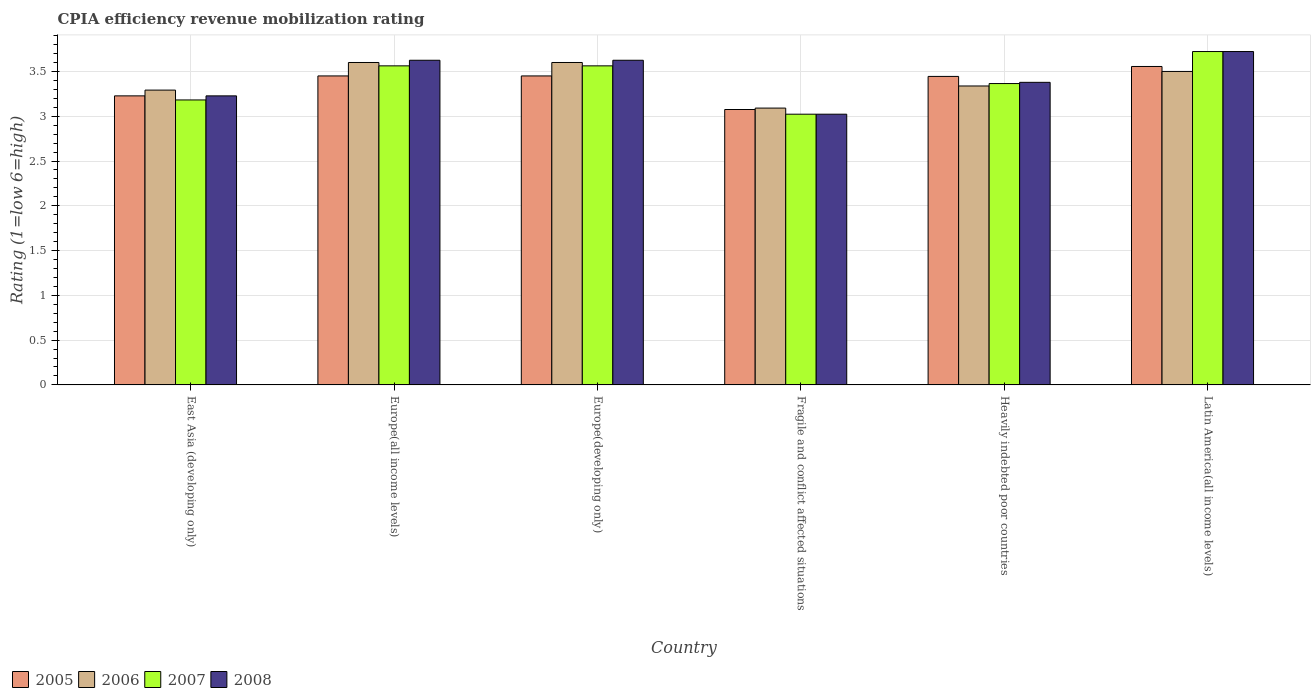How many different coloured bars are there?
Give a very brief answer. 4. Are the number of bars per tick equal to the number of legend labels?
Ensure brevity in your answer.  Yes. What is the label of the 3rd group of bars from the left?
Offer a very short reply. Europe(developing only). In how many cases, is the number of bars for a given country not equal to the number of legend labels?
Provide a succinct answer. 0. What is the CPIA rating in 2005 in Latin America(all income levels)?
Make the answer very short. 3.56. Across all countries, what is the maximum CPIA rating in 2005?
Provide a succinct answer. 3.56. Across all countries, what is the minimum CPIA rating in 2005?
Offer a terse response. 3.08. In which country was the CPIA rating in 2008 maximum?
Offer a terse response. Latin America(all income levels). In which country was the CPIA rating in 2006 minimum?
Your response must be concise. Fragile and conflict affected situations. What is the total CPIA rating in 2008 in the graph?
Your answer should be very brief. 20.6. What is the difference between the CPIA rating in 2005 in Europe(developing only) and that in Heavily indebted poor countries?
Provide a short and direct response. 0.01. What is the difference between the CPIA rating in 2008 in Europe(developing only) and the CPIA rating in 2005 in East Asia (developing only)?
Provide a succinct answer. 0.4. What is the average CPIA rating in 2008 per country?
Your answer should be compact. 3.43. What is the difference between the CPIA rating of/in 2006 and CPIA rating of/in 2005 in Heavily indebted poor countries?
Give a very brief answer. -0.11. What is the ratio of the CPIA rating in 2007 in Europe(all income levels) to that in Heavily indebted poor countries?
Your answer should be compact. 1.06. Is the CPIA rating in 2008 in Europe(developing only) less than that in Latin America(all income levels)?
Provide a short and direct response. Yes. What is the difference between the highest and the second highest CPIA rating in 2005?
Your answer should be compact. -0.11. What is the difference between the highest and the lowest CPIA rating in 2007?
Your answer should be compact. 0.7. In how many countries, is the CPIA rating in 2005 greater than the average CPIA rating in 2005 taken over all countries?
Ensure brevity in your answer.  4. Is the sum of the CPIA rating in 2008 in Europe(developing only) and Heavily indebted poor countries greater than the maximum CPIA rating in 2007 across all countries?
Your answer should be very brief. Yes. Is it the case that in every country, the sum of the CPIA rating in 2005 and CPIA rating in 2006 is greater than the sum of CPIA rating in 2007 and CPIA rating in 2008?
Offer a terse response. No. What does the 4th bar from the left in Latin America(all income levels) represents?
Your answer should be very brief. 2008. Are all the bars in the graph horizontal?
Your answer should be very brief. No. What is the difference between two consecutive major ticks on the Y-axis?
Ensure brevity in your answer.  0.5. Does the graph contain any zero values?
Provide a short and direct response. No. Where does the legend appear in the graph?
Offer a very short reply. Bottom left. How are the legend labels stacked?
Make the answer very short. Horizontal. What is the title of the graph?
Ensure brevity in your answer.  CPIA efficiency revenue mobilization rating. What is the label or title of the X-axis?
Offer a terse response. Country. What is the label or title of the Y-axis?
Offer a terse response. Rating (1=low 6=high). What is the Rating (1=low 6=high) in 2005 in East Asia (developing only)?
Your response must be concise. 3.23. What is the Rating (1=low 6=high) in 2006 in East Asia (developing only)?
Provide a short and direct response. 3.29. What is the Rating (1=low 6=high) of 2007 in East Asia (developing only)?
Your response must be concise. 3.18. What is the Rating (1=low 6=high) of 2008 in East Asia (developing only)?
Make the answer very short. 3.23. What is the Rating (1=low 6=high) of 2005 in Europe(all income levels)?
Provide a short and direct response. 3.45. What is the Rating (1=low 6=high) of 2006 in Europe(all income levels)?
Give a very brief answer. 3.6. What is the Rating (1=low 6=high) of 2007 in Europe(all income levels)?
Offer a terse response. 3.56. What is the Rating (1=low 6=high) in 2008 in Europe(all income levels)?
Keep it short and to the point. 3.62. What is the Rating (1=low 6=high) in 2005 in Europe(developing only)?
Your response must be concise. 3.45. What is the Rating (1=low 6=high) of 2007 in Europe(developing only)?
Your answer should be compact. 3.56. What is the Rating (1=low 6=high) of 2008 in Europe(developing only)?
Make the answer very short. 3.62. What is the Rating (1=low 6=high) in 2005 in Fragile and conflict affected situations?
Make the answer very short. 3.08. What is the Rating (1=low 6=high) of 2006 in Fragile and conflict affected situations?
Provide a succinct answer. 3.09. What is the Rating (1=low 6=high) of 2007 in Fragile and conflict affected situations?
Ensure brevity in your answer.  3.02. What is the Rating (1=low 6=high) in 2008 in Fragile and conflict affected situations?
Offer a very short reply. 3.02. What is the Rating (1=low 6=high) of 2005 in Heavily indebted poor countries?
Make the answer very short. 3.44. What is the Rating (1=low 6=high) in 2006 in Heavily indebted poor countries?
Your answer should be compact. 3.34. What is the Rating (1=low 6=high) of 2007 in Heavily indebted poor countries?
Ensure brevity in your answer.  3.36. What is the Rating (1=low 6=high) of 2008 in Heavily indebted poor countries?
Ensure brevity in your answer.  3.38. What is the Rating (1=low 6=high) of 2005 in Latin America(all income levels)?
Your answer should be compact. 3.56. What is the Rating (1=low 6=high) in 2007 in Latin America(all income levels)?
Ensure brevity in your answer.  3.72. What is the Rating (1=low 6=high) of 2008 in Latin America(all income levels)?
Make the answer very short. 3.72. Across all countries, what is the maximum Rating (1=low 6=high) of 2005?
Provide a succinct answer. 3.56. Across all countries, what is the maximum Rating (1=low 6=high) in 2006?
Your answer should be very brief. 3.6. Across all countries, what is the maximum Rating (1=low 6=high) in 2007?
Provide a succinct answer. 3.72. Across all countries, what is the maximum Rating (1=low 6=high) in 2008?
Provide a succinct answer. 3.72. Across all countries, what is the minimum Rating (1=low 6=high) in 2005?
Your answer should be compact. 3.08. Across all countries, what is the minimum Rating (1=low 6=high) of 2006?
Provide a succinct answer. 3.09. Across all countries, what is the minimum Rating (1=low 6=high) of 2007?
Provide a succinct answer. 3.02. Across all countries, what is the minimum Rating (1=low 6=high) in 2008?
Offer a terse response. 3.02. What is the total Rating (1=low 6=high) in 2005 in the graph?
Make the answer very short. 20.2. What is the total Rating (1=low 6=high) in 2006 in the graph?
Make the answer very short. 20.42. What is the total Rating (1=low 6=high) in 2007 in the graph?
Offer a terse response. 20.42. What is the total Rating (1=low 6=high) in 2008 in the graph?
Keep it short and to the point. 20.6. What is the difference between the Rating (1=low 6=high) of 2005 in East Asia (developing only) and that in Europe(all income levels)?
Your response must be concise. -0.22. What is the difference between the Rating (1=low 6=high) of 2006 in East Asia (developing only) and that in Europe(all income levels)?
Keep it short and to the point. -0.31. What is the difference between the Rating (1=low 6=high) of 2007 in East Asia (developing only) and that in Europe(all income levels)?
Give a very brief answer. -0.38. What is the difference between the Rating (1=low 6=high) of 2008 in East Asia (developing only) and that in Europe(all income levels)?
Provide a succinct answer. -0.4. What is the difference between the Rating (1=low 6=high) in 2005 in East Asia (developing only) and that in Europe(developing only)?
Ensure brevity in your answer.  -0.22. What is the difference between the Rating (1=low 6=high) in 2006 in East Asia (developing only) and that in Europe(developing only)?
Provide a short and direct response. -0.31. What is the difference between the Rating (1=low 6=high) of 2007 in East Asia (developing only) and that in Europe(developing only)?
Offer a terse response. -0.38. What is the difference between the Rating (1=low 6=high) in 2008 in East Asia (developing only) and that in Europe(developing only)?
Your answer should be compact. -0.4. What is the difference between the Rating (1=low 6=high) of 2005 in East Asia (developing only) and that in Fragile and conflict affected situations?
Make the answer very short. 0.15. What is the difference between the Rating (1=low 6=high) of 2006 in East Asia (developing only) and that in Fragile and conflict affected situations?
Your response must be concise. 0.2. What is the difference between the Rating (1=low 6=high) of 2007 in East Asia (developing only) and that in Fragile and conflict affected situations?
Give a very brief answer. 0.16. What is the difference between the Rating (1=low 6=high) in 2008 in East Asia (developing only) and that in Fragile and conflict affected situations?
Provide a short and direct response. 0.2. What is the difference between the Rating (1=low 6=high) in 2005 in East Asia (developing only) and that in Heavily indebted poor countries?
Your response must be concise. -0.22. What is the difference between the Rating (1=low 6=high) in 2006 in East Asia (developing only) and that in Heavily indebted poor countries?
Your answer should be very brief. -0.05. What is the difference between the Rating (1=low 6=high) in 2007 in East Asia (developing only) and that in Heavily indebted poor countries?
Give a very brief answer. -0.18. What is the difference between the Rating (1=low 6=high) of 2008 in East Asia (developing only) and that in Heavily indebted poor countries?
Your answer should be compact. -0.15. What is the difference between the Rating (1=low 6=high) of 2005 in East Asia (developing only) and that in Latin America(all income levels)?
Provide a succinct answer. -0.33. What is the difference between the Rating (1=low 6=high) of 2006 in East Asia (developing only) and that in Latin America(all income levels)?
Provide a succinct answer. -0.21. What is the difference between the Rating (1=low 6=high) of 2007 in East Asia (developing only) and that in Latin America(all income levels)?
Your answer should be compact. -0.54. What is the difference between the Rating (1=low 6=high) in 2008 in East Asia (developing only) and that in Latin America(all income levels)?
Give a very brief answer. -0.49. What is the difference between the Rating (1=low 6=high) in 2008 in Europe(all income levels) and that in Europe(developing only)?
Provide a succinct answer. 0. What is the difference between the Rating (1=low 6=high) of 2006 in Europe(all income levels) and that in Fragile and conflict affected situations?
Make the answer very short. 0.51. What is the difference between the Rating (1=low 6=high) in 2007 in Europe(all income levels) and that in Fragile and conflict affected situations?
Keep it short and to the point. 0.54. What is the difference between the Rating (1=low 6=high) of 2008 in Europe(all income levels) and that in Fragile and conflict affected situations?
Offer a terse response. 0.6. What is the difference between the Rating (1=low 6=high) in 2005 in Europe(all income levels) and that in Heavily indebted poor countries?
Provide a short and direct response. 0.01. What is the difference between the Rating (1=low 6=high) in 2006 in Europe(all income levels) and that in Heavily indebted poor countries?
Your response must be concise. 0.26. What is the difference between the Rating (1=low 6=high) in 2007 in Europe(all income levels) and that in Heavily indebted poor countries?
Make the answer very short. 0.2. What is the difference between the Rating (1=low 6=high) in 2008 in Europe(all income levels) and that in Heavily indebted poor countries?
Offer a very short reply. 0.25. What is the difference between the Rating (1=low 6=high) in 2005 in Europe(all income levels) and that in Latin America(all income levels)?
Ensure brevity in your answer.  -0.11. What is the difference between the Rating (1=low 6=high) in 2006 in Europe(all income levels) and that in Latin America(all income levels)?
Your answer should be compact. 0.1. What is the difference between the Rating (1=low 6=high) of 2007 in Europe(all income levels) and that in Latin America(all income levels)?
Provide a short and direct response. -0.16. What is the difference between the Rating (1=low 6=high) of 2008 in Europe(all income levels) and that in Latin America(all income levels)?
Offer a very short reply. -0.1. What is the difference between the Rating (1=low 6=high) in 2006 in Europe(developing only) and that in Fragile and conflict affected situations?
Offer a terse response. 0.51. What is the difference between the Rating (1=low 6=high) of 2007 in Europe(developing only) and that in Fragile and conflict affected situations?
Provide a succinct answer. 0.54. What is the difference between the Rating (1=low 6=high) of 2008 in Europe(developing only) and that in Fragile and conflict affected situations?
Give a very brief answer. 0.6. What is the difference between the Rating (1=low 6=high) in 2005 in Europe(developing only) and that in Heavily indebted poor countries?
Ensure brevity in your answer.  0.01. What is the difference between the Rating (1=low 6=high) of 2006 in Europe(developing only) and that in Heavily indebted poor countries?
Your response must be concise. 0.26. What is the difference between the Rating (1=low 6=high) of 2007 in Europe(developing only) and that in Heavily indebted poor countries?
Offer a very short reply. 0.2. What is the difference between the Rating (1=low 6=high) in 2008 in Europe(developing only) and that in Heavily indebted poor countries?
Offer a terse response. 0.25. What is the difference between the Rating (1=low 6=high) in 2005 in Europe(developing only) and that in Latin America(all income levels)?
Offer a very short reply. -0.11. What is the difference between the Rating (1=low 6=high) of 2007 in Europe(developing only) and that in Latin America(all income levels)?
Offer a terse response. -0.16. What is the difference between the Rating (1=low 6=high) of 2008 in Europe(developing only) and that in Latin America(all income levels)?
Give a very brief answer. -0.1. What is the difference between the Rating (1=low 6=high) in 2005 in Fragile and conflict affected situations and that in Heavily indebted poor countries?
Offer a terse response. -0.37. What is the difference between the Rating (1=low 6=high) of 2006 in Fragile and conflict affected situations and that in Heavily indebted poor countries?
Provide a short and direct response. -0.25. What is the difference between the Rating (1=low 6=high) in 2007 in Fragile and conflict affected situations and that in Heavily indebted poor countries?
Offer a very short reply. -0.34. What is the difference between the Rating (1=low 6=high) in 2008 in Fragile and conflict affected situations and that in Heavily indebted poor countries?
Provide a succinct answer. -0.36. What is the difference between the Rating (1=low 6=high) in 2005 in Fragile and conflict affected situations and that in Latin America(all income levels)?
Give a very brief answer. -0.48. What is the difference between the Rating (1=low 6=high) in 2006 in Fragile and conflict affected situations and that in Latin America(all income levels)?
Keep it short and to the point. -0.41. What is the difference between the Rating (1=low 6=high) of 2007 in Fragile and conflict affected situations and that in Latin America(all income levels)?
Give a very brief answer. -0.7. What is the difference between the Rating (1=low 6=high) of 2008 in Fragile and conflict affected situations and that in Latin America(all income levels)?
Give a very brief answer. -0.7. What is the difference between the Rating (1=low 6=high) in 2005 in Heavily indebted poor countries and that in Latin America(all income levels)?
Your response must be concise. -0.11. What is the difference between the Rating (1=low 6=high) in 2006 in Heavily indebted poor countries and that in Latin America(all income levels)?
Provide a short and direct response. -0.16. What is the difference between the Rating (1=low 6=high) of 2007 in Heavily indebted poor countries and that in Latin America(all income levels)?
Provide a succinct answer. -0.36. What is the difference between the Rating (1=low 6=high) in 2008 in Heavily indebted poor countries and that in Latin America(all income levels)?
Keep it short and to the point. -0.34. What is the difference between the Rating (1=low 6=high) in 2005 in East Asia (developing only) and the Rating (1=low 6=high) in 2006 in Europe(all income levels)?
Your response must be concise. -0.37. What is the difference between the Rating (1=low 6=high) in 2005 in East Asia (developing only) and the Rating (1=low 6=high) in 2007 in Europe(all income levels)?
Offer a terse response. -0.34. What is the difference between the Rating (1=low 6=high) in 2005 in East Asia (developing only) and the Rating (1=low 6=high) in 2008 in Europe(all income levels)?
Your answer should be very brief. -0.4. What is the difference between the Rating (1=low 6=high) of 2006 in East Asia (developing only) and the Rating (1=low 6=high) of 2007 in Europe(all income levels)?
Your response must be concise. -0.27. What is the difference between the Rating (1=low 6=high) of 2006 in East Asia (developing only) and the Rating (1=low 6=high) of 2008 in Europe(all income levels)?
Your answer should be very brief. -0.33. What is the difference between the Rating (1=low 6=high) of 2007 in East Asia (developing only) and the Rating (1=low 6=high) of 2008 in Europe(all income levels)?
Your response must be concise. -0.44. What is the difference between the Rating (1=low 6=high) of 2005 in East Asia (developing only) and the Rating (1=low 6=high) of 2006 in Europe(developing only)?
Your response must be concise. -0.37. What is the difference between the Rating (1=low 6=high) in 2005 in East Asia (developing only) and the Rating (1=low 6=high) in 2007 in Europe(developing only)?
Your response must be concise. -0.34. What is the difference between the Rating (1=low 6=high) of 2005 in East Asia (developing only) and the Rating (1=low 6=high) of 2008 in Europe(developing only)?
Ensure brevity in your answer.  -0.4. What is the difference between the Rating (1=low 6=high) of 2006 in East Asia (developing only) and the Rating (1=low 6=high) of 2007 in Europe(developing only)?
Make the answer very short. -0.27. What is the difference between the Rating (1=low 6=high) of 2006 in East Asia (developing only) and the Rating (1=low 6=high) of 2008 in Europe(developing only)?
Make the answer very short. -0.33. What is the difference between the Rating (1=low 6=high) of 2007 in East Asia (developing only) and the Rating (1=low 6=high) of 2008 in Europe(developing only)?
Your response must be concise. -0.44. What is the difference between the Rating (1=low 6=high) of 2005 in East Asia (developing only) and the Rating (1=low 6=high) of 2006 in Fragile and conflict affected situations?
Offer a terse response. 0.14. What is the difference between the Rating (1=low 6=high) of 2005 in East Asia (developing only) and the Rating (1=low 6=high) of 2007 in Fragile and conflict affected situations?
Offer a terse response. 0.2. What is the difference between the Rating (1=low 6=high) in 2005 in East Asia (developing only) and the Rating (1=low 6=high) in 2008 in Fragile and conflict affected situations?
Offer a very short reply. 0.2. What is the difference between the Rating (1=low 6=high) of 2006 in East Asia (developing only) and the Rating (1=low 6=high) of 2007 in Fragile and conflict affected situations?
Provide a succinct answer. 0.27. What is the difference between the Rating (1=low 6=high) of 2006 in East Asia (developing only) and the Rating (1=low 6=high) of 2008 in Fragile and conflict affected situations?
Provide a succinct answer. 0.27. What is the difference between the Rating (1=low 6=high) of 2007 in East Asia (developing only) and the Rating (1=low 6=high) of 2008 in Fragile and conflict affected situations?
Your answer should be compact. 0.16. What is the difference between the Rating (1=low 6=high) of 2005 in East Asia (developing only) and the Rating (1=low 6=high) of 2006 in Heavily indebted poor countries?
Provide a succinct answer. -0.11. What is the difference between the Rating (1=low 6=high) of 2005 in East Asia (developing only) and the Rating (1=low 6=high) of 2007 in Heavily indebted poor countries?
Your response must be concise. -0.14. What is the difference between the Rating (1=low 6=high) of 2005 in East Asia (developing only) and the Rating (1=low 6=high) of 2008 in Heavily indebted poor countries?
Your response must be concise. -0.15. What is the difference between the Rating (1=low 6=high) in 2006 in East Asia (developing only) and the Rating (1=low 6=high) in 2007 in Heavily indebted poor countries?
Your response must be concise. -0.07. What is the difference between the Rating (1=low 6=high) of 2006 in East Asia (developing only) and the Rating (1=low 6=high) of 2008 in Heavily indebted poor countries?
Provide a succinct answer. -0.09. What is the difference between the Rating (1=low 6=high) of 2007 in East Asia (developing only) and the Rating (1=low 6=high) of 2008 in Heavily indebted poor countries?
Provide a succinct answer. -0.2. What is the difference between the Rating (1=low 6=high) in 2005 in East Asia (developing only) and the Rating (1=low 6=high) in 2006 in Latin America(all income levels)?
Ensure brevity in your answer.  -0.27. What is the difference between the Rating (1=low 6=high) in 2005 in East Asia (developing only) and the Rating (1=low 6=high) in 2007 in Latin America(all income levels)?
Provide a succinct answer. -0.49. What is the difference between the Rating (1=low 6=high) of 2005 in East Asia (developing only) and the Rating (1=low 6=high) of 2008 in Latin America(all income levels)?
Your answer should be compact. -0.49. What is the difference between the Rating (1=low 6=high) of 2006 in East Asia (developing only) and the Rating (1=low 6=high) of 2007 in Latin America(all income levels)?
Your answer should be compact. -0.43. What is the difference between the Rating (1=low 6=high) of 2006 in East Asia (developing only) and the Rating (1=low 6=high) of 2008 in Latin America(all income levels)?
Offer a very short reply. -0.43. What is the difference between the Rating (1=low 6=high) of 2007 in East Asia (developing only) and the Rating (1=low 6=high) of 2008 in Latin America(all income levels)?
Make the answer very short. -0.54. What is the difference between the Rating (1=low 6=high) of 2005 in Europe(all income levels) and the Rating (1=low 6=high) of 2006 in Europe(developing only)?
Give a very brief answer. -0.15. What is the difference between the Rating (1=low 6=high) in 2005 in Europe(all income levels) and the Rating (1=low 6=high) in 2007 in Europe(developing only)?
Keep it short and to the point. -0.11. What is the difference between the Rating (1=low 6=high) of 2005 in Europe(all income levels) and the Rating (1=low 6=high) of 2008 in Europe(developing only)?
Your response must be concise. -0.17. What is the difference between the Rating (1=low 6=high) of 2006 in Europe(all income levels) and the Rating (1=low 6=high) of 2007 in Europe(developing only)?
Your answer should be compact. 0.04. What is the difference between the Rating (1=low 6=high) of 2006 in Europe(all income levels) and the Rating (1=low 6=high) of 2008 in Europe(developing only)?
Keep it short and to the point. -0.03. What is the difference between the Rating (1=low 6=high) of 2007 in Europe(all income levels) and the Rating (1=low 6=high) of 2008 in Europe(developing only)?
Give a very brief answer. -0.06. What is the difference between the Rating (1=low 6=high) of 2005 in Europe(all income levels) and the Rating (1=low 6=high) of 2006 in Fragile and conflict affected situations?
Your response must be concise. 0.36. What is the difference between the Rating (1=low 6=high) of 2005 in Europe(all income levels) and the Rating (1=low 6=high) of 2007 in Fragile and conflict affected situations?
Provide a short and direct response. 0.43. What is the difference between the Rating (1=low 6=high) of 2005 in Europe(all income levels) and the Rating (1=low 6=high) of 2008 in Fragile and conflict affected situations?
Make the answer very short. 0.43. What is the difference between the Rating (1=low 6=high) of 2006 in Europe(all income levels) and the Rating (1=low 6=high) of 2007 in Fragile and conflict affected situations?
Offer a terse response. 0.58. What is the difference between the Rating (1=low 6=high) in 2006 in Europe(all income levels) and the Rating (1=low 6=high) in 2008 in Fragile and conflict affected situations?
Keep it short and to the point. 0.58. What is the difference between the Rating (1=low 6=high) of 2007 in Europe(all income levels) and the Rating (1=low 6=high) of 2008 in Fragile and conflict affected situations?
Keep it short and to the point. 0.54. What is the difference between the Rating (1=low 6=high) of 2005 in Europe(all income levels) and the Rating (1=low 6=high) of 2006 in Heavily indebted poor countries?
Your response must be concise. 0.11. What is the difference between the Rating (1=low 6=high) of 2005 in Europe(all income levels) and the Rating (1=low 6=high) of 2007 in Heavily indebted poor countries?
Offer a terse response. 0.09. What is the difference between the Rating (1=low 6=high) of 2005 in Europe(all income levels) and the Rating (1=low 6=high) of 2008 in Heavily indebted poor countries?
Offer a very short reply. 0.07. What is the difference between the Rating (1=low 6=high) in 2006 in Europe(all income levels) and the Rating (1=low 6=high) in 2007 in Heavily indebted poor countries?
Your response must be concise. 0.24. What is the difference between the Rating (1=low 6=high) in 2006 in Europe(all income levels) and the Rating (1=low 6=high) in 2008 in Heavily indebted poor countries?
Make the answer very short. 0.22. What is the difference between the Rating (1=low 6=high) in 2007 in Europe(all income levels) and the Rating (1=low 6=high) in 2008 in Heavily indebted poor countries?
Provide a succinct answer. 0.18. What is the difference between the Rating (1=low 6=high) in 2005 in Europe(all income levels) and the Rating (1=low 6=high) in 2007 in Latin America(all income levels)?
Offer a terse response. -0.27. What is the difference between the Rating (1=low 6=high) in 2005 in Europe(all income levels) and the Rating (1=low 6=high) in 2008 in Latin America(all income levels)?
Ensure brevity in your answer.  -0.27. What is the difference between the Rating (1=low 6=high) in 2006 in Europe(all income levels) and the Rating (1=low 6=high) in 2007 in Latin America(all income levels)?
Provide a succinct answer. -0.12. What is the difference between the Rating (1=low 6=high) in 2006 in Europe(all income levels) and the Rating (1=low 6=high) in 2008 in Latin America(all income levels)?
Offer a very short reply. -0.12. What is the difference between the Rating (1=low 6=high) of 2007 in Europe(all income levels) and the Rating (1=low 6=high) of 2008 in Latin America(all income levels)?
Make the answer very short. -0.16. What is the difference between the Rating (1=low 6=high) of 2005 in Europe(developing only) and the Rating (1=low 6=high) of 2006 in Fragile and conflict affected situations?
Your answer should be very brief. 0.36. What is the difference between the Rating (1=low 6=high) of 2005 in Europe(developing only) and the Rating (1=low 6=high) of 2007 in Fragile and conflict affected situations?
Keep it short and to the point. 0.43. What is the difference between the Rating (1=low 6=high) in 2005 in Europe(developing only) and the Rating (1=low 6=high) in 2008 in Fragile and conflict affected situations?
Your answer should be very brief. 0.43. What is the difference between the Rating (1=low 6=high) of 2006 in Europe(developing only) and the Rating (1=low 6=high) of 2007 in Fragile and conflict affected situations?
Make the answer very short. 0.58. What is the difference between the Rating (1=low 6=high) of 2006 in Europe(developing only) and the Rating (1=low 6=high) of 2008 in Fragile and conflict affected situations?
Ensure brevity in your answer.  0.58. What is the difference between the Rating (1=low 6=high) in 2007 in Europe(developing only) and the Rating (1=low 6=high) in 2008 in Fragile and conflict affected situations?
Offer a terse response. 0.54. What is the difference between the Rating (1=low 6=high) of 2005 in Europe(developing only) and the Rating (1=low 6=high) of 2006 in Heavily indebted poor countries?
Make the answer very short. 0.11. What is the difference between the Rating (1=low 6=high) in 2005 in Europe(developing only) and the Rating (1=low 6=high) in 2007 in Heavily indebted poor countries?
Your response must be concise. 0.09. What is the difference between the Rating (1=low 6=high) of 2005 in Europe(developing only) and the Rating (1=low 6=high) of 2008 in Heavily indebted poor countries?
Give a very brief answer. 0.07. What is the difference between the Rating (1=low 6=high) of 2006 in Europe(developing only) and the Rating (1=low 6=high) of 2007 in Heavily indebted poor countries?
Keep it short and to the point. 0.24. What is the difference between the Rating (1=low 6=high) of 2006 in Europe(developing only) and the Rating (1=low 6=high) of 2008 in Heavily indebted poor countries?
Give a very brief answer. 0.22. What is the difference between the Rating (1=low 6=high) of 2007 in Europe(developing only) and the Rating (1=low 6=high) of 2008 in Heavily indebted poor countries?
Offer a terse response. 0.18. What is the difference between the Rating (1=low 6=high) in 2005 in Europe(developing only) and the Rating (1=low 6=high) in 2006 in Latin America(all income levels)?
Provide a succinct answer. -0.05. What is the difference between the Rating (1=low 6=high) in 2005 in Europe(developing only) and the Rating (1=low 6=high) in 2007 in Latin America(all income levels)?
Provide a succinct answer. -0.27. What is the difference between the Rating (1=low 6=high) of 2005 in Europe(developing only) and the Rating (1=low 6=high) of 2008 in Latin America(all income levels)?
Your answer should be compact. -0.27. What is the difference between the Rating (1=low 6=high) in 2006 in Europe(developing only) and the Rating (1=low 6=high) in 2007 in Latin America(all income levels)?
Your response must be concise. -0.12. What is the difference between the Rating (1=low 6=high) in 2006 in Europe(developing only) and the Rating (1=low 6=high) in 2008 in Latin America(all income levels)?
Provide a succinct answer. -0.12. What is the difference between the Rating (1=low 6=high) of 2007 in Europe(developing only) and the Rating (1=low 6=high) of 2008 in Latin America(all income levels)?
Provide a succinct answer. -0.16. What is the difference between the Rating (1=low 6=high) in 2005 in Fragile and conflict affected situations and the Rating (1=low 6=high) in 2006 in Heavily indebted poor countries?
Your answer should be compact. -0.26. What is the difference between the Rating (1=low 6=high) in 2005 in Fragile and conflict affected situations and the Rating (1=low 6=high) in 2007 in Heavily indebted poor countries?
Ensure brevity in your answer.  -0.29. What is the difference between the Rating (1=low 6=high) of 2005 in Fragile and conflict affected situations and the Rating (1=low 6=high) of 2008 in Heavily indebted poor countries?
Provide a short and direct response. -0.3. What is the difference between the Rating (1=low 6=high) of 2006 in Fragile and conflict affected situations and the Rating (1=low 6=high) of 2007 in Heavily indebted poor countries?
Provide a succinct answer. -0.27. What is the difference between the Rating (1=low 6=high) of 2006 in Fragile and conflict affected situations and the Rating (1=low 6=high) of 2008 in Heavily indebted poor countries?
Offer a terse response. -0.29. What is the difference between the Rating (1=low 6=high) in 2007 in Fragile and conflict affected situations and the Rating (1=low 6=high) in 2008 in Heavily indebted poor countries?
Ensure brevity in your answer.  -0.36. What is the difference between the Rating (1=low 6=high) in 2005 in Fragile and conflict affected situations and the Rating (1=low 6=high) in 2006 in Latin America(all income levels)?
Keep it short and to the point. -0.42. What is the difference between the Rating (1=low 6=high) in 2005 in Fragile and conflict affected situations and the Rating (1=low 6=high) in 2007 in Latin America(all income levels)?
Your response must be concise. -0.65. What is the difference between the Rating (1=low 6=high) in 2005 in Fragile and conflict affected situations and the Rating (1=low 6=high) in 2008 in Latin America(all income levels)?
Ensure brevity in your answer.  -0.65. What is the difference between the Rating (1=low 6=high) in 2006 in Fragile and conflict affected situations and the Rating (1=low 6=high) in 2007 in Latin America(all income levels)?
Ensure brevity in your answer.  -0.63. What is the difference between the Rating (1=low 6=high) of 2006 in Fragile and conflict affected situations and the Rating (1=low 6=high) of 2008 in Latin America(all income levels)?
Give a very brief answer. -0.63. What is the difference between the Rating (1=low 6=high) of 2007 in Fragile and conflict affected situations and the Rating (1=low 6=high) of 2008 in Latin America(all income levels)?
Your answer should be compact. -0.7. What is the difference between the Rating (1=low 6=high) in 2005 in Heavily indebted poor countries and the Rating (1=low 6=high) in 2006 in Latin America(all income levels)?
Keep it short and to the point. -0.06. What is the difference between the Rating (1=low 6=high) in 2005 in Heavily indebted poor countries and the Rating (1=low 6=high) in 2007 in Latin America(all income levels)?
Your answer should be very brief. -0.28. What is the difference between the Rating (1=low 6=high) in 2005 in Heavily indebted poor countries and the Rating (1=low 6=high) in 2008 in Latin America(all income levels)?
Offer a terse response. -0.28. What is the difference between the Rating (1=low 6=high) of 2006 in Heavily indebted poor countries and the Rating (1=low 6=high) of 2007 in Latin America(all income levels)?
Your answer should be very brief. -0.38. What is the difference between the Rating (1=low 6=high) of 2006 in Heavily indebted poor countries and the Rating (1=low 6=high) of 2008 in Latin America(all income levels)?
Offer a very short reply. -0.38. What is the difference between the Rating (1=low 6=high) in 2007 in Heavily indebted poor countries and the Rating (1=low 6=high) in 2008 in Latin America(all income levels)?
Provide a short and direct response. -0.36. What is the average Rating (1=low 6=high) of 2005 per country?
Your answer should be very brief. 3.37. What is the average Rating (1=low 6=high) of 2006 per country?
Your answer should be compact. 3.4. What is the average Rating (1=low 6=high) of 2007 per country?
Give a very brief answer. 3.4. What is the average Rating (1=low 6=high) in 2008 per country?
Your response must be concise. 3.43. What is the difference between the Rating (1=low 6=high) in 2005 and Rating (1=low 6=high) in 2006 in East Asia (developing only)?
Your response must be concise. -0.06. What is the difference between the Rating (1=low 6=high) of 2005 and Rating (1=low 6=high) of 2007 in East Asia (developing only)?
Your response must be concise. 0.05. What is the difference between the Rating (1=low 6=high) of 2005 and Rating (1=low 6=high) of 2008 in East Asia (developing only)?
Provide a succinct answer. 0. What is the difference between the Rating (1=low 6=high) of 2006 and Rating (1=low 6=high) of 2007 in East Asia (developing only)?
Offer a very short reply. 0.11. What is the difference between the Rating (1=low 6=high) of 2006 and Rating (1=low 6=high) of 2008 in East Asia (developing only)?
Ensure brevity in your answer.  0.06. What is the difference between the Rating (1=low 6=high) of 2007 and Rating (1=low 6=high) of 2008 in East Asia (developing only)?
Your answer should be very brief. -0.05. What is the difference between the Rating (1=low 6=high) in 2005 and Rating (1=low 6=high) in 2006 in Europe(all income levels)?
Make the answer very short. -0.15. What is the difference between the Rating (1=low 6=high) of 2005 and Rating (1=low 6=high) of 2007 in Europe(all income levels)?
Provide a short and direct response. -0.11. What is the difference between the Rating (1=low 6=high) in 2005 and Rating (1=low 6=high) in 2008 in Europe(all income levels)?
Offer a terse response. -0.17. What is the difference between the Rating (1=low 6=high) in 2006 and Rating (1=low 6=high) in 2007 in Europe(all income levels)?
Your answer should be compact. 0.04. What is the difference between the Rating (1=low 6=high) in 2006 and Rating (1=low 6=high) in 2008 in Europe(all income levels)?
Your answer should be compact. -0.03. What is the difference between the Rating (1=low 6=high) in 2007 and Rating (1=low 6=high) in 2008 in Europe(all income levels)?
Your answer should be very brief. -0.06. What is the difference between the Rating (1=low 6=high) of 2005 and Rating (1=low 6=high) of 2007 in Europe(developing only)?
Give a very brief answer. -0.11. What is the difference between the Rating (1=low 6=high) of 2005 and Rating (1=low 6=high) of 2008 in Europe(developing only)?
Your answer should be very brief. -0.17. What is the difference between the Rating (1=low 6=high) of 2006 and Rating (1=low 6=high) of 2007 in Europe(developing only)?
Offer a terse response. 0.04. What is the difference between the Rating (1=low 6=high) of 2006 and Rating (1=low 6=high) of 2008 in Europe(developing only)?
Give a very brief answer. -0.03. What is the difference between the Rating (1=low 6=high) in 2007 and Rating (1=low 6=high) in 2008 in Europe(developing only)?
Make the answer very short. -0.06. What is the difference between the Rating (1=low 6=high) in 2005 and Rating (1=low 6=high) in 2006 in Fragile and conflict affected situations?
Keep it short and to the point. -0.02. What is the difference between the Rating (1=low 6=high) in 2005 and Rating (1=low 6=high) in 2007 in Fragile and conflict affected situations?
Your answer should be very brief. 0.05. What is the difference between the Rating (1=low 6=high) in 2005 and Rating (1=low 6=high) in 2008 in Fragile and conflict affected situations?
Offer a terse response. 0.05. What is the difference between the Rating (1=low 6=high) in 2006 and Rating (1=low 6=high) in 2007 in Fragile and conflict affected situations?
Your answer should be very brief. 0.07. What is the difference between the Rating (1=low 6=high) of 2006 and Rating (1=low 6=high) of 2008 in Fragile and conflict affected situations?
Offer a very short reply. 0.07. What is the difference between the Rating (1=low 6=high) of 2005 and Rating (1=low 6=high) of 2006 in Heavily indebted poor countries?
Keep it short and to the point. 0.11. What is the difference between the Rating (1=low 6=high) of 2005 and Rating (1=low 6=high) of 2007 in Heavily indebted poor countries?
Offer a terse response. 0.08. What is the difference between the Rating (1=low 6=high) of 2005 and Rating (1=low 6=high) of 2008 in Heavily indebted poor countries?
Offer a terse response. 0.07. What is the difference between the Rating (1=low 6=high) in 2006 and Rating (1=low 6=high) in 2007 in Heavily indebted poor countries?
Your answer should be compact. -0.03. What is the difference between the Rating (1=low 6=high) of 2006 and Rating (1=low 6=high) of 2008 in Heavily indebted poor countries?
Make the answer very short. -0.04. What is the difference between the Rating (1=low 6=high) in 2007 and Rating (1=low 6=high) in 2008 in Heavily indebted poor countries?
Give a very brief answer. -0.01. What is the difference between the Rating (1=low 6=high) in 2005 and Rating (1=low 6=high) in 2006 in Latin America(all income levels)?
Your answer should be very brief. 0.06. What is the difference between the Rating (1=low 6=high) of 2005 and Rating (1=low 6=high) of 2007 in Latin America(all income levels)?
Your answer should be compact. -0.17. What is the difference between the Rating (1=low 6=high) of 2006 and Rating (1=low 6=high) of 2007 in Latin America(all income levels)?
Offer a very short reply. -0.22. What is the difference between the Rating (1=low 6=high) in 2006 and Rating (1=low 6=high) in 2008 in Latin America(all income levels)?
Offer a terse response. -0.22. What is the difference between the Rating (1=low 6=high) of 2007 and Rating (1=low 6=high) of 2008 in Latin America(all income levels)?
Your answer should be very brief. 0. What is the ratio of the Rating (1=low 6=high) of 2005 in East Asia (developing only) to that in Europe(all income levels)?
Offer a terse response. 0.94. What is the ratio of the Rating (1=low 6=high) in 2006 in East Asia (developing only) to that in Europe(all income levels)?
Keep it short and to the point. 0.91. What is the ratio of the Rating (1=low 6=high) in 2007 in East Asia (developing only) to that in Europe(all income levels)?
Provide a short and direct response. 0.89. What is the ratio of the Rating (1=low 6=high) of 2008 in East Asia (developing only) to that in Europe(all income levels)?
Provide a succinct answer. 0.89. What is the ratio of the Rating (1=low 6=high) in 2005 in East Asia (developing only) to that in Europe(developing only)?
Your response must be concise. 0.94. What is the ratio of the Rating (1=low 6=high) of 2006 in East Asia (developing only) to that in Europe(developing only)?
Your answer should be very brief. 0.91. What is the ratio of the Rating (1=low 6=high) of 2007 in East Asia (developing only) to that in Europe(developing only)?
Your answer should be very brief. 0.89. What is the ratio of the Rating (1=low 6=high) of 2008 in East Asia (developing only) to that in Europe(developing only)?
Make the answer very short. 0.89. What is the ratio of the Rating (1=low 6=high) in 2005 in East Asia (developing only) to that in Fragile and conflict affected situations?
Keep it short and to the point. 1.05. What is the ratio of the Rating (1=low 6=high) in 2006 in East Asia (developing only) to that in Fragile and conflict affected situations?
Provide a succinct answer. 1.06. What is the ratio of the Rating (1=low 6=high) in 2007 in East Asia (developing only) to that in Fragile and conflict affected situations?
Your answer should be very brief. 1.05. What is the ratio of the Rating (1=low 6=high) of 2008 in East Asia (developing only) to that in Fragile and conflict affected situations?
Your answer should be very brief. 1.07. What is the ratio of the Rating (1=low 6=high) in 2005 in East Asia (developing only) to that in Heavily indebted poor countries?
Offer a very short reply. 0.94. What is the ratio of the Rating (1=low 6=high) of 2006 in East Asia (developing only) to that in Heavily indebted poor countries?
Make the answer very short. 0.99. What is the ratio of the Rating (1=low 6=high) in 2007 in East Asia (developing only) to that in Heavily indebted poor countries?
Offer a very short reply. 0.95. What is the ratio of the Rating (1=low 6=high) of 2008 in East Asia (developing only) to that in Heavily indebted poor countries?
Provide a succinct answer. 0.96. What is the ratio of the Rating (1=low 6=high) in 2005 in East Asia (developing only) to that in Latin America(all income levels)?
Make the answer very short. 0.91. What is the ratio of the Rating (1=low 6=high) of 2006 in East Asia (developing only) to that in Latin America(all income levels)?
Provide a short and direct response. 0.94. What is the ratio of the Rating (1=low 6=high) of 2007 in East Asia (developing only) to that in Latin America(all income levels)?
Make the answer very short. 0.85. What is the ratio of the Rating (1=low 6=high) in 2008 in East Asia (developing only) to that in Latin America(all income levels)?
Your answer should be very brief. 0.87. What is the ratio of the Rating (1=low 6=high) in 2005 in Europe(all income levels) to that in Europe(developing only)?
Give a very brief answer. 1. What is the ratio of the Rating (1=low 6=high) in 2005 in Europe(all income levels) to that in Fragile and conflict affected situations?
Ensure brevity in your answer.  1.12. What is the ratio of the Rating (1=low 6=high) of 2006 in Europe(all income levels) to that in Fragile and conflict affected situations?
Offer a very short reply. 1.16. What is the ratio of the Rating (1=low 6=high) of 2007 in Europe(all income levels) to that in Fragile and conflict affected situations?
Ensure brevity in your answer.  1.18. What is the ratio of the Rating (1=low 6=high) of 2008 in Europe(all income levels) to that in Fragile and conflict affected situations?
Offer a very short reply. 1.2. What is the ratio of the Rating (1=low 6=high) of 2005 in Europe(all income levels) to that in Heavily indebted poor countries?
Offer a very short reply. 1. What is the ratio of the Rating (1=low 6=high) of 2006 in Europe(all income levels) to that in Heavily indebted poor countries?
Give a very brief answer. 1.08. What is the ratio of the Rating (1=low 6=high) of 2007 in Europe(all income levels) to that in Heavily indebted poor countries?
Ensure brevity in your answer.  1.06. What is the ratio of the Rating (1=low 6=high) in 2008 in Europe(all income levels) to that in Heavily indebted poor countries?
Ensure brevity in your answer.  1.07. What is the ratio of the Rating (1=low 6=high) in 2005 in Europe(all income levels) to that in Latin America(all income levels)?
Your response must be concise. 0.97. What is the ratio of the Rating (1=low 6=high) of 2006 in Europe(all income levels) to that in Latin America(all income levels)?
Your answer should be compact. 1.03. What is the ratio of the Rating (1=low 6=high) in 2007 in Europe(all income levels) to that in Latin America(all income levels)?
Offer a very short reply. 0.96. What is the ratio of the Rating (1=low 6=high) in 2008 in Europe(all income levels) to that in Latin America(all income levels)?
Your answer should be compact. 0.97. What is the ratio of the Rating (1=low 6=high) of 2005 in Europe(developing only) to that in Fragile and conflict affected situations?
Your response must be concise. 1.12. What is the ratio of the Rating (1=low 6=high) of 2006 in Europe(developing only) to that in Fragile and conflict affected situations?
Offer a very short reply. 1.16. What is the ratio of the Rating (1=low 6=high) in 2007 in Europe(developing only) to that in Fragile and conflict affected situations?
Make the answer very short. 1.18. What is the ratio of the Rating (1=low 6=high) of 2008 in Europe(developing only) to that in Fragile and conflict affected situations?
Offer a terse response. 1.2. What is the ratio of the Rating (1=low 6=high) of 2005 in Europe(developing only) to that in Heavily indebted poor countries?
Provide a succinct answer. 1. What is the ratio of the Rating (1=low 6=high) of 2006 in Europe(developing only) to that in Heavily indebted poor countries?
Your answer should be very brief. 1.08. What is the ratio of the Rating (1=low 6=high) in 2007 in Europe(developing only) to that in Heavily indebted poor countries?
Offer a terse response. 1.06. What is the ratio of the Rating (1=low 6=high) of 2008 in Europe(developing only) to that in Heavily indebted poor countries?
Your answer should be very brief. 1.07. What is the ratio of the Rating (1=low 6=high) of 2005 in Europe(developing only) to that in Latin America(all income levels)?
Provide a short and direct response. 0.97. What is the ratio of the Rating (1=low 6=high) in 2006 in Europe(developing only) to that in Latin America(all income levels)?
Give a very brief answer. 1.03. What is the ratio of the Rating (1=low 6=high) of 2007 in Europe(developing only) to that in Latin America(all income levels)?
Ensure brevity in your answer.  0.96. What is the ratio of the Rating (1=low 6=high) of 2008 in Europe(developing only) to that in Latin America(all income levels)?
Provide a short and direct response. 0.97. What is the ratio of the Rating (1=low 6=high) in 2005 in Fragile and conflict affected situations to that in Heavily indebted poor countries?
Your answer should be very brief. 0.89. What is the ratio of the Rating (1=low 6=high) of 2006 in Fragile and conflict affected situations to that in Heavily indebted poor countries?
Your answer should be compact. 0.93. What is the ratio of the Rating (1=low 6=high) in 2007 in Fragile and conflict affected situations to that in Heavily indebted poor countries?
Provide a succinct answer. 0.9. What is the ratio of the Rating (1=low 6=high) in 2008 in Fragile and conflict affected situations to that in Heavily indebted poor countries?
Offer a terse response. 0.89. What is the ratio of the Rating (1=low 6=high) of 2005 in Fragile and conflict affected situations to that in Latin America(all income levels)?
Provide a short and direct response. 0.86. What is the ratio of the Rating (1=low 6=high) of 2006 in Fragile and conflict affected situations to that in Latin America(all income levels)?
Your answer should be compact. 0.88. What is the ratio of the Rating (1=low 6=high) in 2007 in Fragile and conflict affected situations to that in Latin America(all income levels)?
Offer a terse response. 0.81. What is the ratio of the Rating (1=low 6=high) in 2008 in Fragile and conflict affected situations to that in Latin America(all income levels)?
Ensure brevity in your answer.  0.81. What is the ratio of the Rating (1=low 6=high) of 2005 in Heavily indebted poor countries to that in Latin America(all income levels)?
Make the answer very short. 0.97. What is the ratio of the Rating (1=low 6=high) in 2006 in Heavily indebted poor countries to that in Latin America(all income levels)?
Offer a very short reply. 0.95. What is the ratio of the Rating (1=low 6=high) of 2007 in Heavily indebted poor countries to that in Latin America(all income levels)?
Keep it short and to the point. 0.9. What is the ratio of the Rating (1=low 6=high) in 2008 in Heavily indebted poor countries to that in Latin America(all income levels)?
Your answer should be compact. 0.91. What is the difference between the highest and the second highest Rating (1=low 6=high) in 2005?
Your response must be concise. 0.11. What is the difference between the highest and the second highest Rating (1=low 6=high) of 2006?
Offer a very short reply. 0. What is the difference between the highest and the second highest Rating (1=low 6=high) in 2007?
Your answer should be very brief. 0.16. What is the difference between the highest and the second highest Rating (1=low 6=high) in 2008?
Ensure brevity in your answer.  0.1. What is the difference between the highest and the lowest Rating (1=low 6=high) in 2005?
Offer a terse response. 0.48. What is the difference between the highest and the lowest Rating (1=low 6=high) in 2006?
Keep it short and to the point. 0.51. What is the difference between the highest and the lowest Rating (1=low 6=high) of 2007?
Keep it short and to the point. 0.7. What is the difference between the highest and the lowest Rating (1=low 6=high) of 2008?
Your response must be concise. 0.7. 